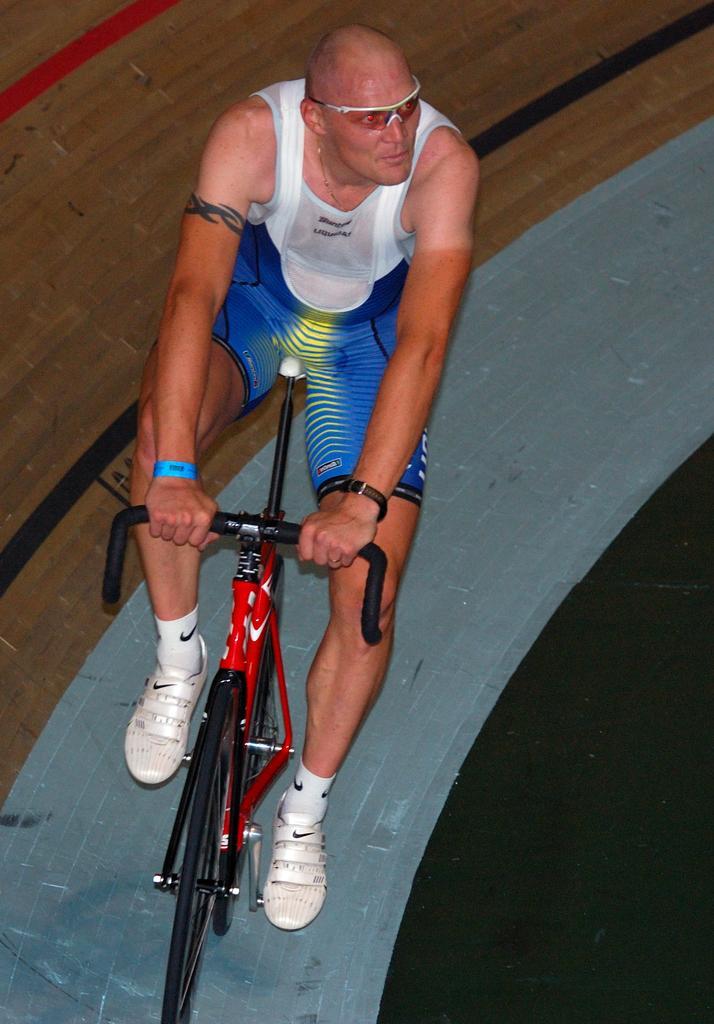Could you give a brief overview of what you see in this image? This picture is mainly highlighted with a man wearing goggles, wrist band and riding a bicycle. 